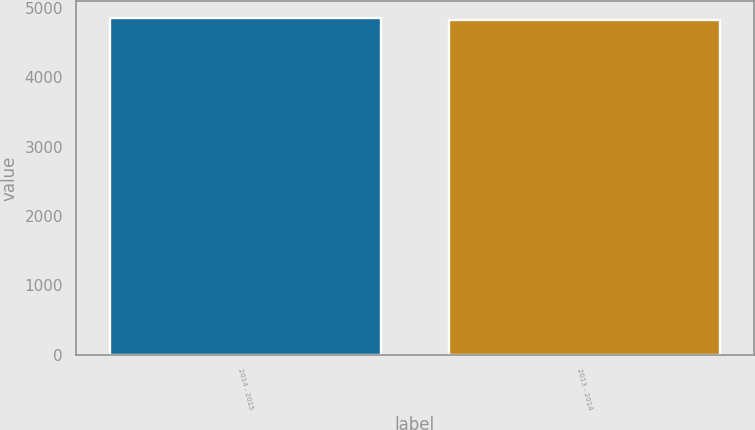Convert chart to OTSL. <chart><loc_0><loc_0><loc_500><loc_500><bar_chart><fcel>2014 - 2015<fcel>2013 - 2014<nl><fcel>4857.7<fcel>4820.4<nl></chart> 